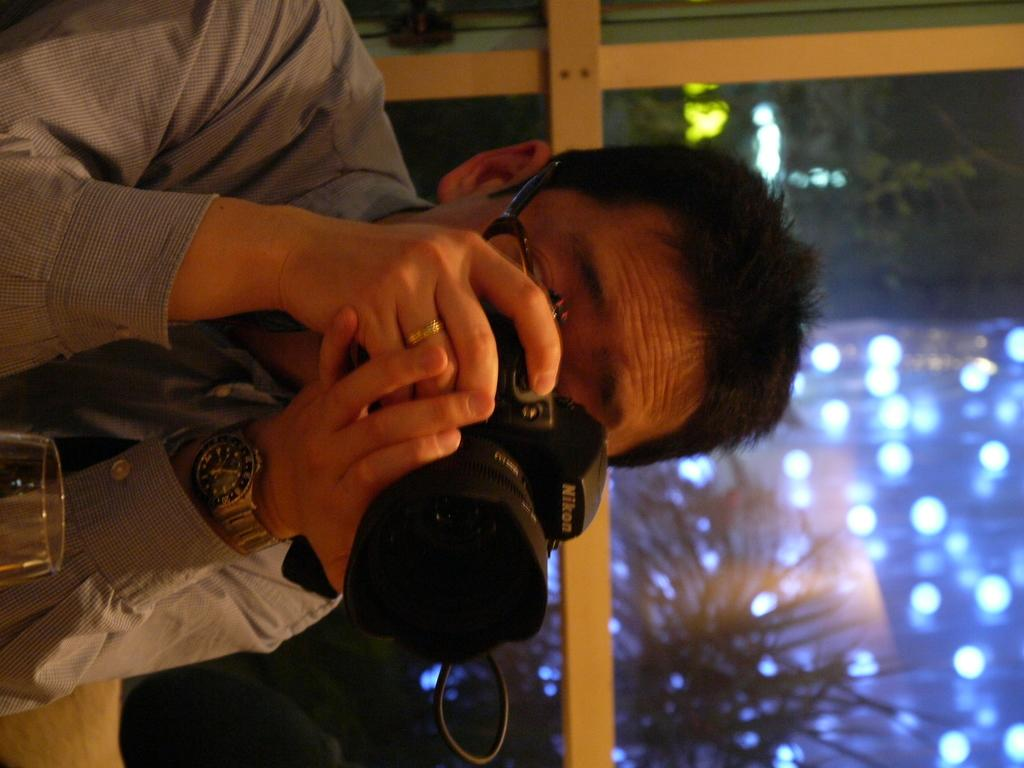What color is the shirt that the person is wearing in the image? The person is wearing a grey shirt. What is the person holding in his hands? The person is holding a camera in his hands. What object is in front of the person? There is a glass in front of the person. What can be seen in the background of the image? There is a window in the background. What type of substance is dripping from the branch in the image? There is no branch or substance present in the image. 